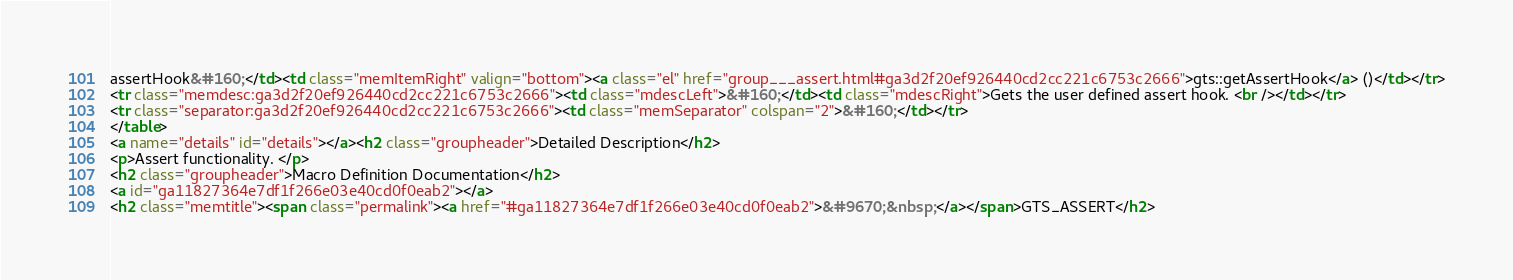Convert code to text. <code><loc_0><loc_0><loc_500><loc_500><_HTML_>assertHook&#160;</td><td class="memItemRight" valign="bottom"><a class="el" href="group___assert.html#ga3d2f20ef926440cd2cc221c6753c2666">gts::getAssertHook</a> ()</td></tr>
<tr class="memdesc:ga3d2f20ef926440cd2cc221c6753c2666"><td class="mdescLeft">&#160;</td><td class="mdescRight">Gets the user defined assert hook. <br /></td></tr>
<tr class="separator:ga3d2f20ef926440cd2cc221c6753c2666"><td class="memSeparator" colspan="2">&#160;</td></tr>
</table>
<a name="details" id="details"></a><h2 class="groupheader">Detailed Description</h2>
<p>Assert functionality. </p>
<h2 class="groupheader">Macro Definition Documentation</h2>
<a id="ga11827364e7df1f266e03e40cd0f0eab2"></a>
<h2 class="memtitle"><span class="permalink"><a href="#ga11827364e7df1f266e03e40cd0f0eab2">&#9670;&nbsp;</a></span>GTS_ASSERT</h2>
</code> 